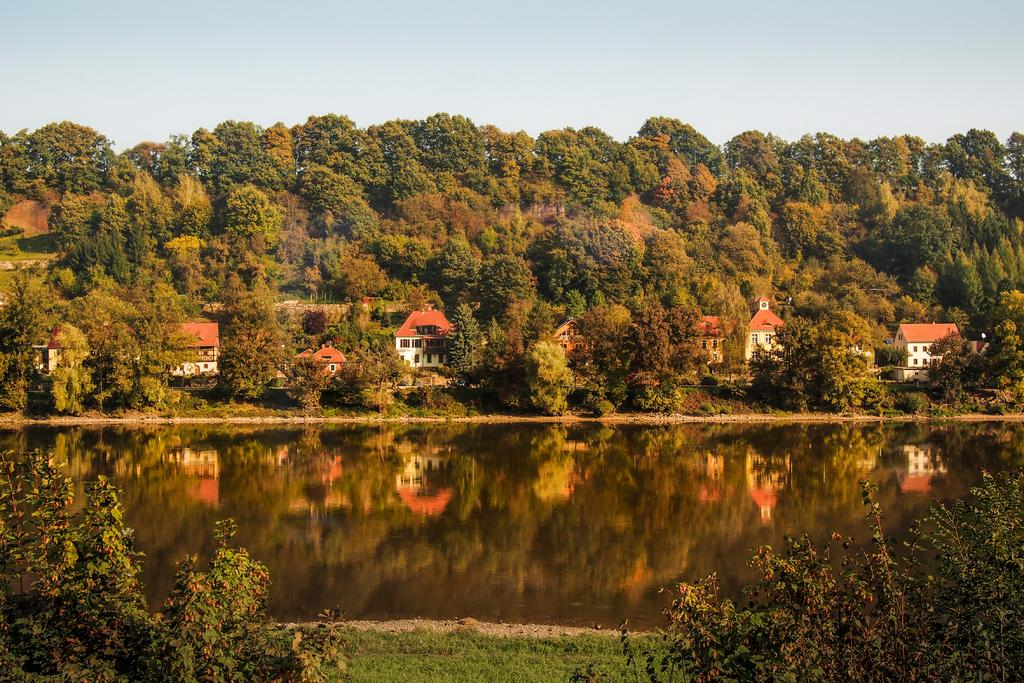What type of structures can be seen in the image? There are houses in the image. What type of vegetation is present in the image? There are trees and grass in the image. What natural element can be seen in the image? There is water in the image. What is visible in the background of the image? The sky is visible in the background of the image. What type of flower is being played on the instrument in the image? There is no flower or instrument present in the image. 